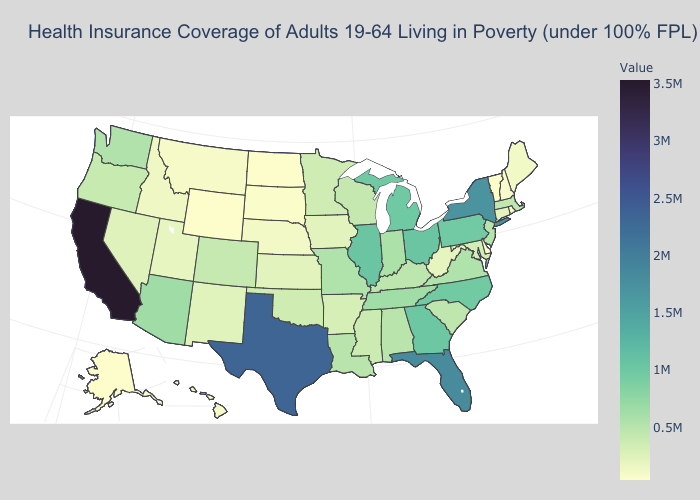Among the states that border Idaho , which have the lowest value?
Answer briefly. Wyoming. Does the map have missing data?
Give a very brief answer. No. Does Georgia have a higher value than California?
Give a very brief answer. No. Is the legend a continuous bar?
Write a very short answer. Yes. Which states hav the highest value in the South?
Quick response, please. Texas. Which states have the highest value in the USA?
Short answer required. California. Does California have the highest value in the USA?
Concise answer only. Yes. Does the map have missing data?
Quick response, please. No. 